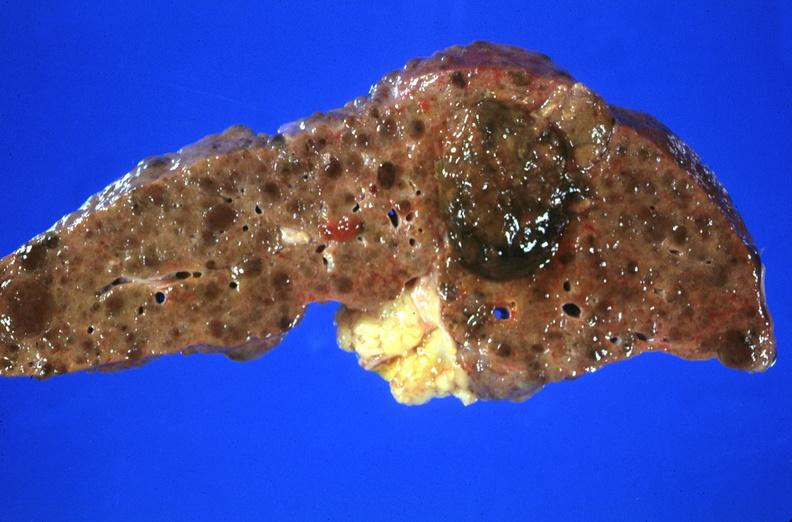s exact cause present?
Answer the question using a single word or phrase. No 